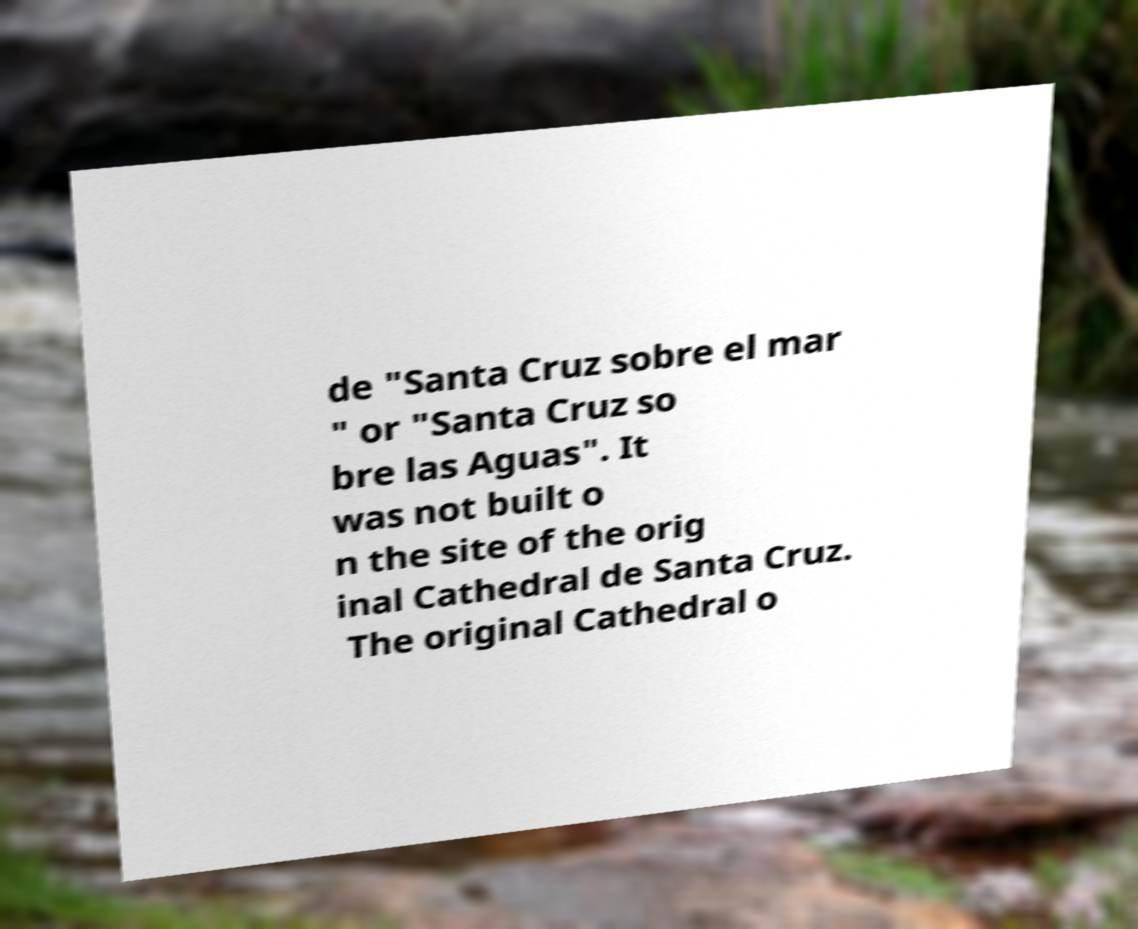Can you accurately transcribe the text from the provided image for me? de "Santa Cruz sobre el mar " or "Santa Cruz so bre las Aguas". It was not built o n the site of the orig inal Cathedral de Santa Cruz. The original Cathedral o 